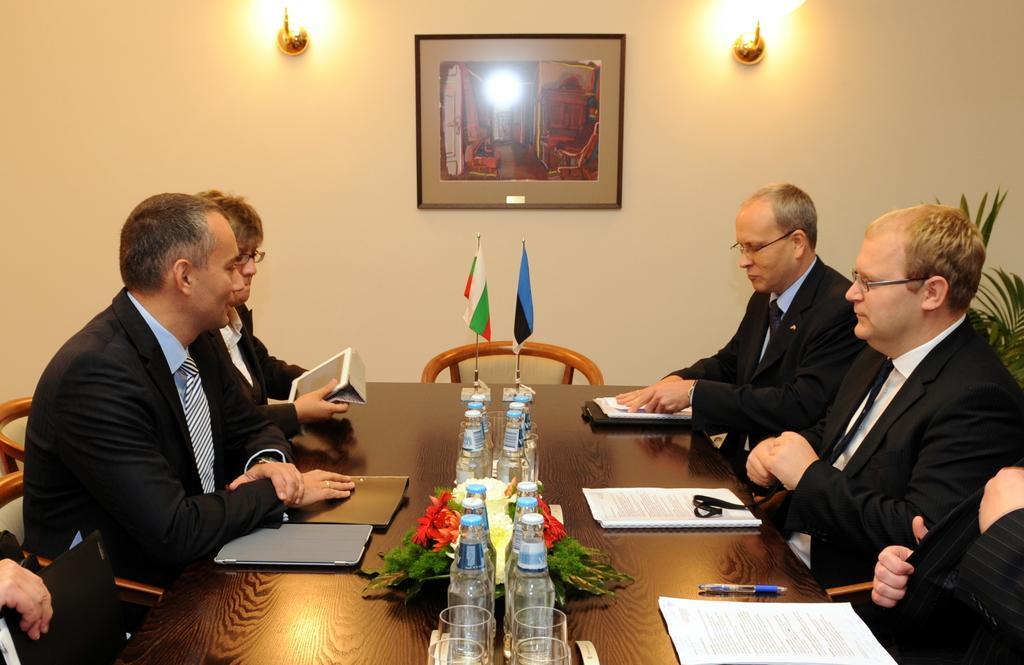Can you describe this image briefly? There are group of persons sitting on chairs and there is a table in front of them which has books,water bottles,glasses and two flags on it and there is a picture which is attached to the wall in the background. 